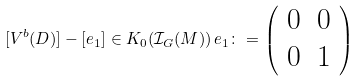<formula> <loc_0><loc_0><loc_500><loc_500>[ V ^ { b } ( D ) ] - [ e _ { 1 } ] \in K _ { 0 } ( \mathcal { I } _ { G } ( M ) ) \, e _ { 1 } \colon = \left ( \begin{array} { c c } 0 & 0 \\ 0 & 1 \end{array} \right )</formula> 